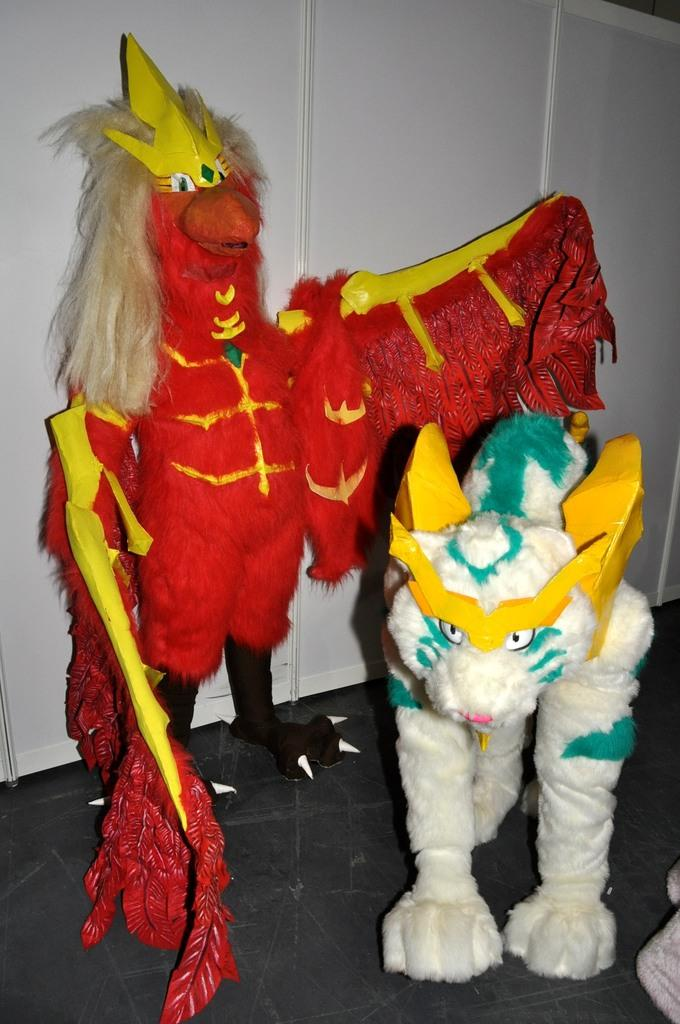What is located in the center of the image? There are soft toys in the center of the image. What can be seen in the background of the image? There are cupboards in the background of the image. What part of the room is visible at the bottom of the image? The floor is visible at the bottom of the image. What type of punishment is being administered to the tomatoes in the image? There are no tomatoes present in the image, so it is not possible to determine if any punishment is being administered. 